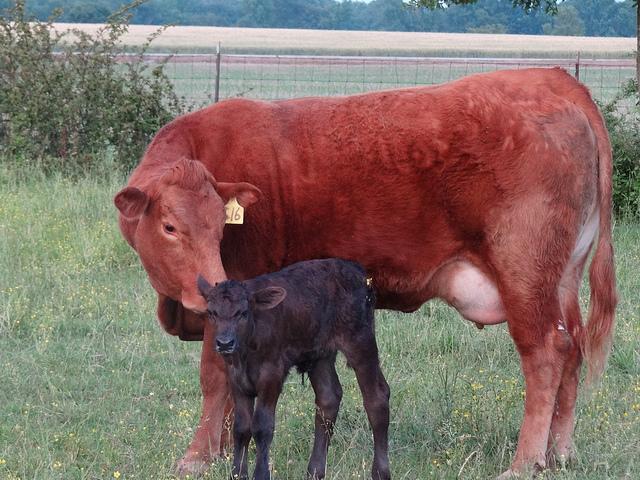How many cows can you see?
Give a very brief answer. 2. 